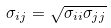Convert formula to latex. <formula><loc_0><loc_0><loc_500><loc_500>\sigma _ { i j } = \sqrt { \sigma _ { i i } \sigma _ { j j } }</formula> 